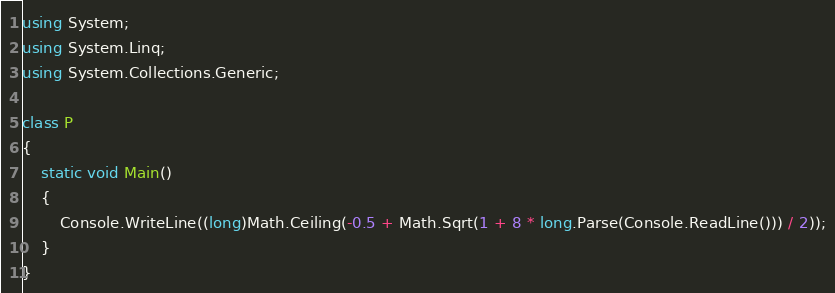Convert code to text. <code><loc_0><loc_0><loc_500><loc_500><_C#_>using System;
using System.Linq;
using System.Collections.Generic;

class P
{
    static void Main()
    {
        Console.WriteLine((long)Math.Ceiling(-0.5 + Math.Sqrt(1 + 8 * long.Parse(Console.ReadLine())) / 2));
    }
}</code> 